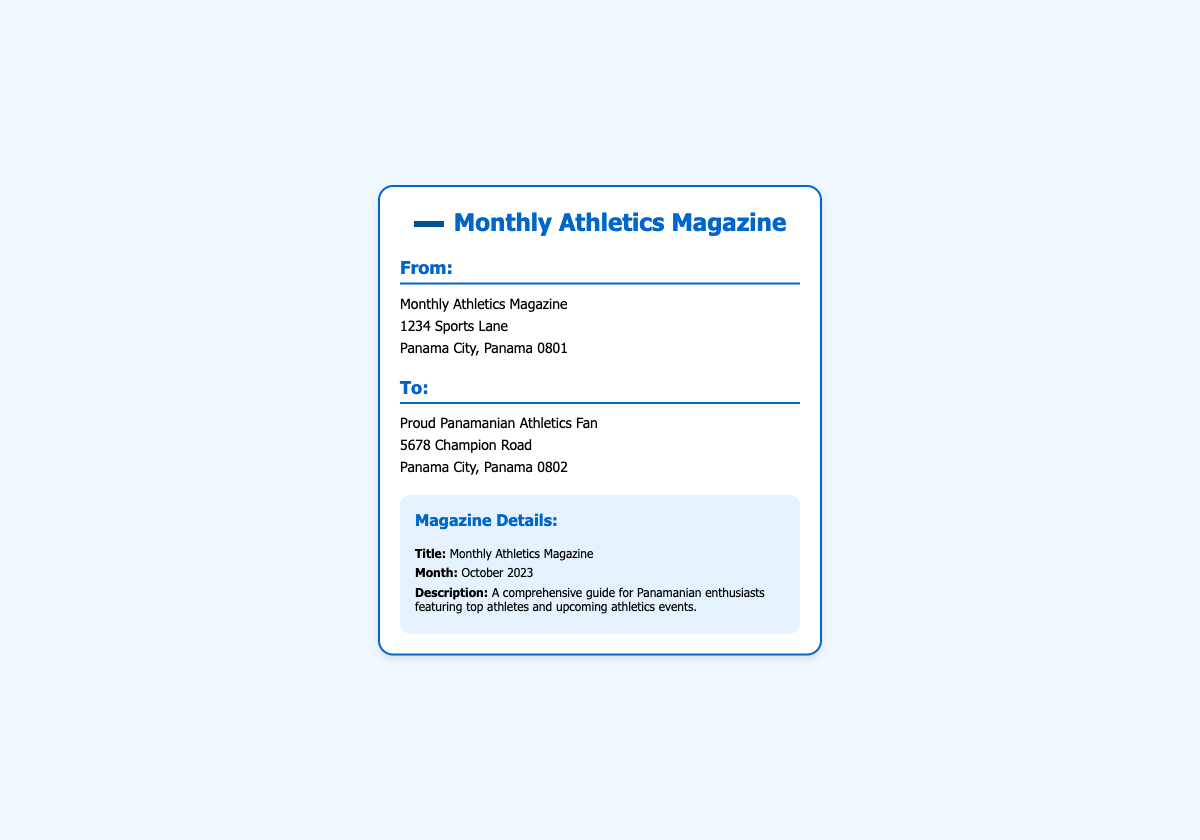What is the sender's address? The sender's address is located in the "From" section of the document, which includes "Monthly Athletics Magazine, 1234 Sports Lane, Panama City, Panama 0801."
Answer: Monthly Athletics Magazine, 1234 Sports Lane, Panama City, Panama 0801 What is the recipient's name? The recipient's name is provided in the "To" section of the document, indicating who the label is addressed to.
Answer: Proud Panamanian Athletics Fan What is the month of the magazine? The month of the magazine is indicated in the "Magazine Details" section, which specifies the publication period.
Answer: October 2023 What is the title of the magazine? The title of the magazine is stated in the "Magazine Details" section, giving clear identification of the publication.
Answer: Monthly Athletics Magazine What is the magazine's description? The description is found in the "Magazine Details" section, providing a brief overview of the magazine's content.
Answer: A comprehensive guide for Panamanian enthusiasts featuring top athletes and upcoming athletics events Why is this magazine relevant for Panamanian fans? The magazine is specifically tailored as a guide for Panamanian enthusiasts, highlighting its targeted audience's interests.
Answer: It features top athletes and upcoming athletics events What type of document is this? This document serves as a shipping label, which includes sender and recipient information, along with details about the package being shipped.
Answer: Shipping label Where is the magazine being sent from? The shipping label specifies the point of origin in the "From" section, which identifies the sender's location.
Answer: Panama City, Panama What color is the shipping label's border? The color of the shipping label's border is explicitly described in the styling elements of the document.
Answer: #0066cc 